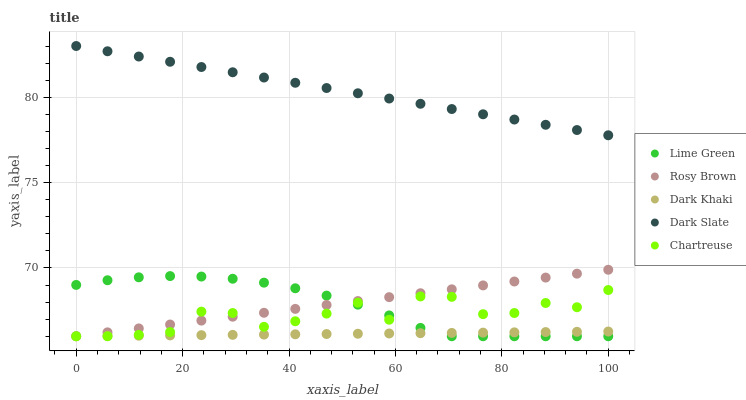Does Dark Khaki have the minimum area under the curve?
Answer yes or no. Yes. Does Dark Slate have the maximum area under the curve?
Answer yes or no. Yes. Does Chartreuse have the minimum area under the curve?
Answer yes or no. No. Does Chartreuse have the maximum area under the curve?
Answer yes or no. No. Is Rosy Brown the smoothest?
Answer yes or no. Yes. Is Chartreuse the roughest?
Answer yes or no. Yes. Is Dark Slate the smoothest?
Answer yes or no. No. Is Dark Slate the roughest?
Answer yes or no. No. Does Dark Khaki have the lowest value?
Answer yes or no. Yes. Does Dark Slate have the lowest value?
Answer yes or no. No. Does Dark Slate have the highest value?
Answer yes or no. Yes. Does Chartreuse have the highest value?
Answer yes or no. No. Is Dark Khaki less than Dark Slate?
Answer yes or no. Yes. Is Dark Slate greater than Lime Green?
Answer yes or no. Yes. Does Rosy Brown intersect Lime Green?
Answer yes or no. Yes. Is Rosy Brown less than Lime Green?
Answer yes or no. No. Is Rosy Brown greater than Lime Green?
Answer yes or no. No. Does Dark Khaki intersect Dark Slate?
Answer yes or no. No. 